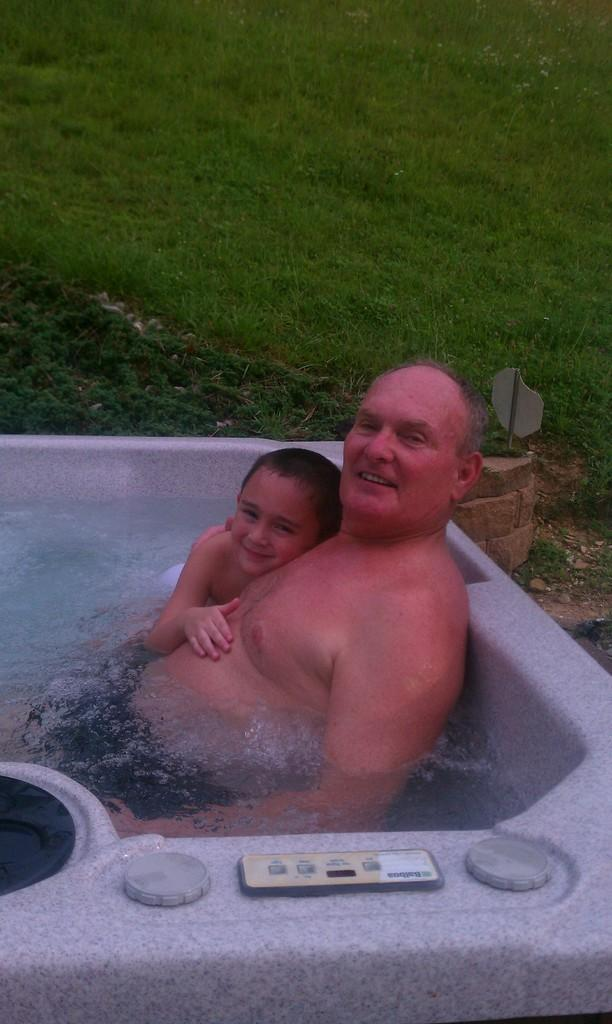How many people are in the image? There are two persons in the image. What are the two persons doing in the image? The two persons are sitting in a water tub. What type of vegetation can be seen in the image? There is grass visible in the image. What color is the cap on the van in the image? There is no van or cap present in the image. How many clovers can be seen growing in the grass in the image? There is no mention of clovers in the image, only grass is visible. 